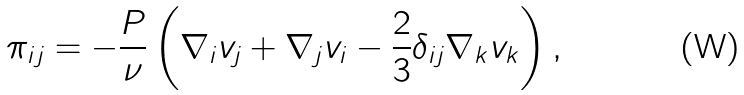Convert formula to latex. <formula><loc_0><loc_0><loc_500><loc_500>\pi _ { i j } = - \frac { P } { \nu } \left ( \nabla _ { i } v _ { j } + \nabla _ { j } v _ { i } - \frac { 2 } { 3 } \delta _ { i j } \nabla _ { k } v _ { k } \right ) ,</formula> 